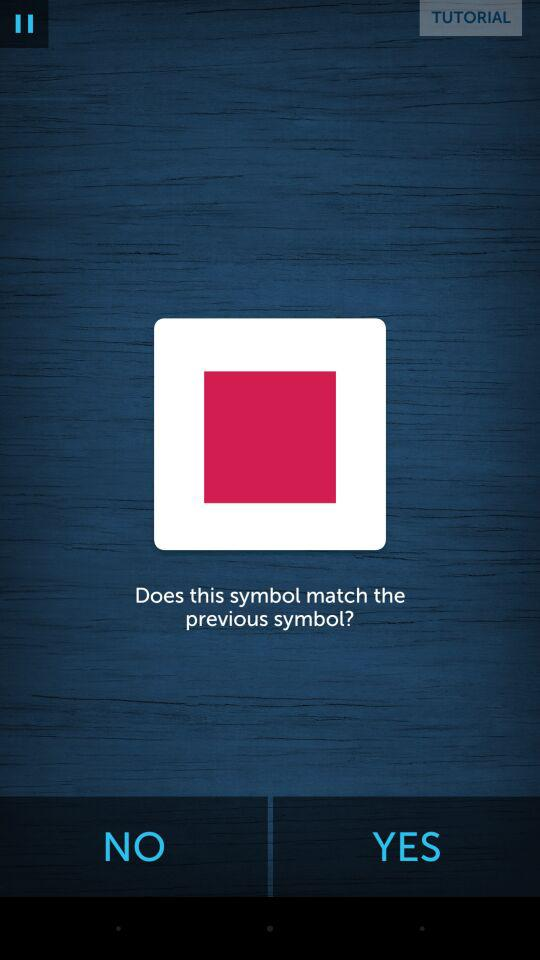What is the application name? The application name is "Lumosity". 